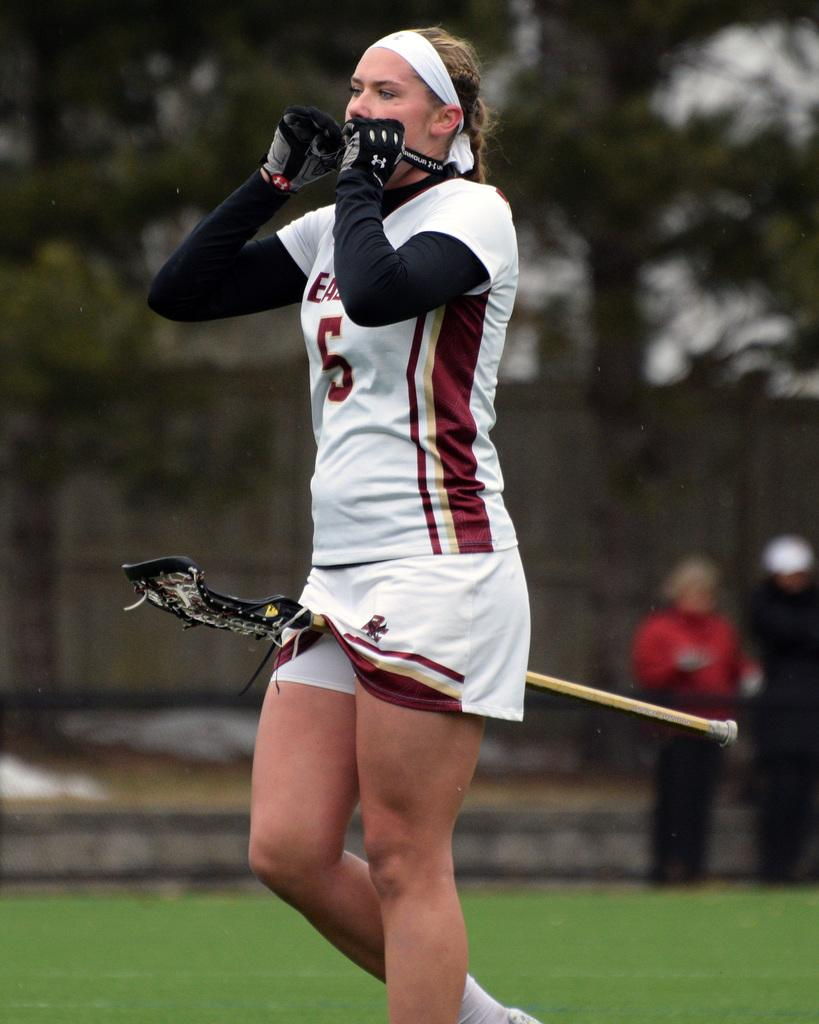What is the primary subject of the image? There is a woman standing in the image. What other objects or creatures are present in the image? There is a bat and a tree in the image. How many people are visible in the image? There are two people standing in the image. How many chairs can be seen in the image? There are no chairs present in the image. What type of hen is sitting on the woman's shoulder in the image? There is no hen present in the image. 